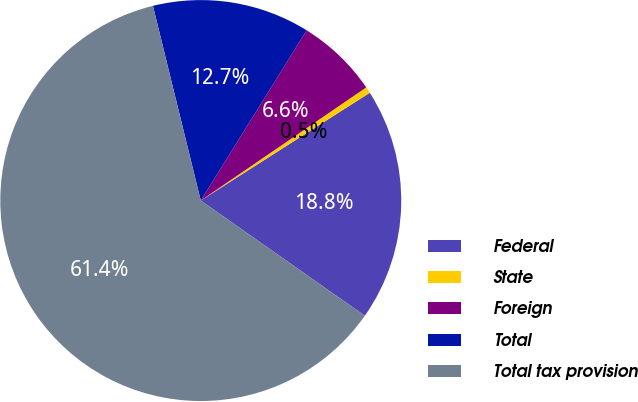<chart> <loc_0><loc_0><loc_500><loc_500><pie_chart><fcel>Federal<fcel>State<fcel>Foreign<fcel>Total<fcel>Total tax provision<nl><fcel>18.78%<fcel>0.51%<fcel>6.6%<fcel>12.69%<fcel>61.42%<nl></chart> 